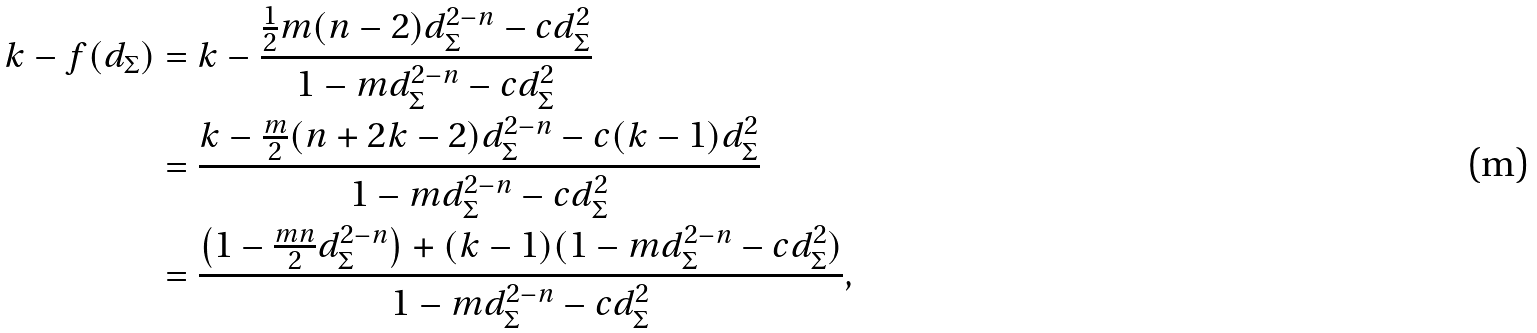<formula> <loc_0><loc_0><loc_500><loc_500>k - f ( d _ { \Sigma } ) & = k - \frac { \frac { 1 } { 2 } m ( n - 2 ) d _ { \Sigma } ^ { 2 - n } - c d _ { \Sigma } ^ { 2 } } { 1 - m d _ { \Sigma } ^ { 2 - n } - c d _ { \Sigma } ^ { 2 } } \\ & = \frac { k - \frac { m } { 2 } ( n + 2 k - 2 ) d _ { \Sigma } ^ { 2 - n } - c ( k - 1 ) d _ { \Sigma } ^ { 2 } } { 1 - m d _ { \Sigma } ^ { 2 - n } - c d _ { \Sigma } ^ { 2 } } \\ & = \frac { \left ( 1 - \frac { m n } { 2 } d _ { \Sigma } ^ { 2 - n } \right ) + ( k - 1 ) ( 1 - m d _ { \Sigma } ^ { 2 - n } - c d _ { \Sigma } ^ { 2 } ) } { 1 - m d _ { \Sigma } ^ { 2 - n } - c d _ { \Sigma } ^ { 2 } } ,</formula> 